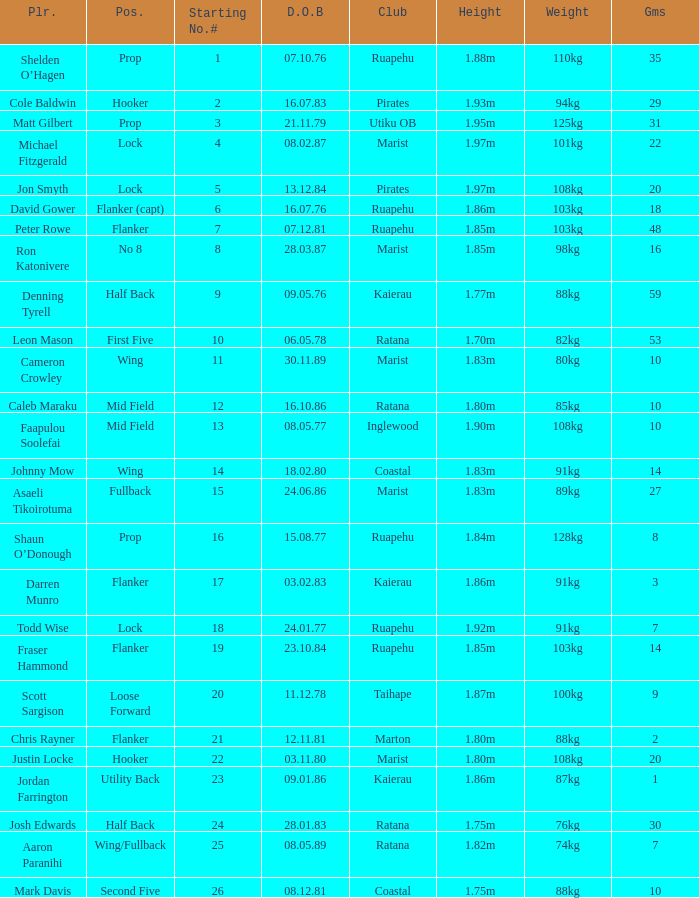Which player weighs 76kg? Josh Edwards. 